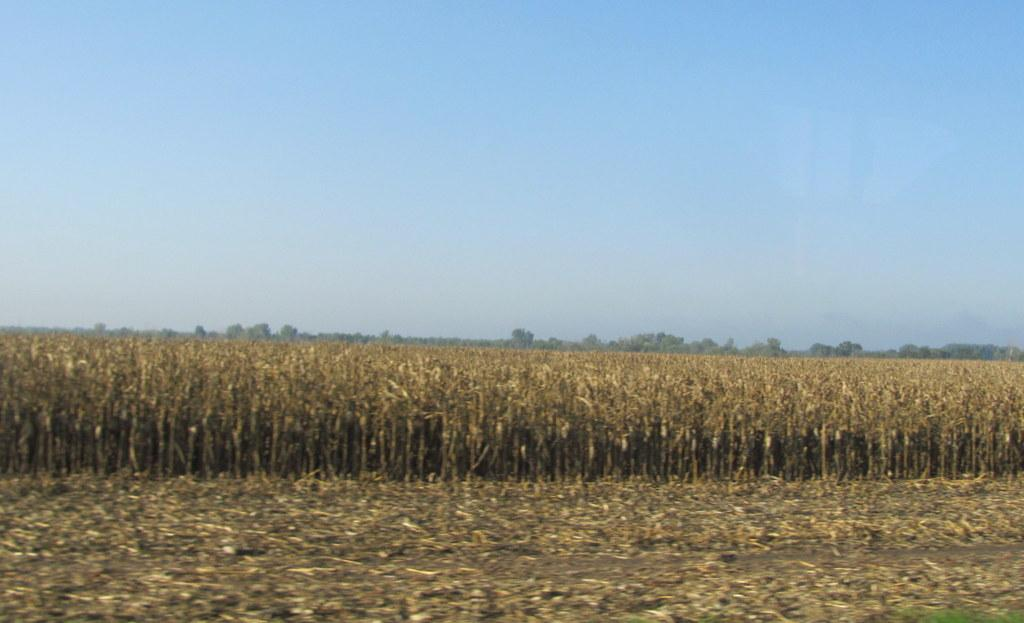What type of vegetation can be seen in the image? There are crops and trees in the image. What part of the natural environment is visible in the image? The sky is visible in the image. What type of learning can be observed in the image? There is no learning activity present in the image; it features crops, trees, and the sky. What type of approval is required for the things in the image? There is no approval process mentioned or implied in the image, as it simply depicts natural elements like crops, trees, and the sky. 